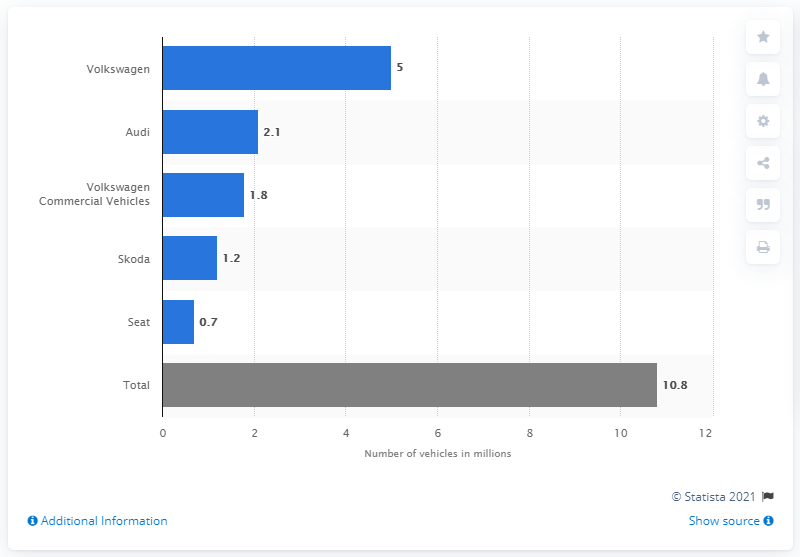Identify some key points in this picture. The number of Skoda vehicles affected by the software scandal ranges from 1.2 to... 